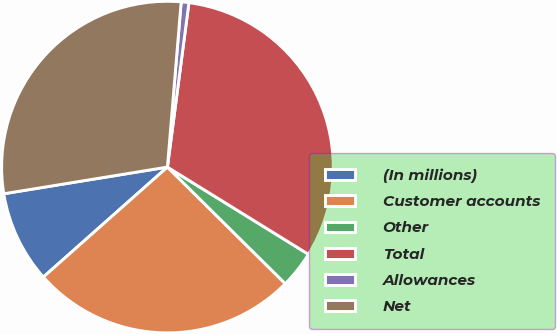Convert chart. <chart><loc_0><loc_0><loc_500><loc_500><pie_chart><fcel>(In millions)<fcel>Customer accounts<fcel>Other<fcel>Total<fcel>Allowances<fcel>Net<nl><fcel>8.97%<fcel>26.04%<fcel>3.6%<fcel>31.74%<fcel>0.75%<fcel>28.89%<nl></chart> 